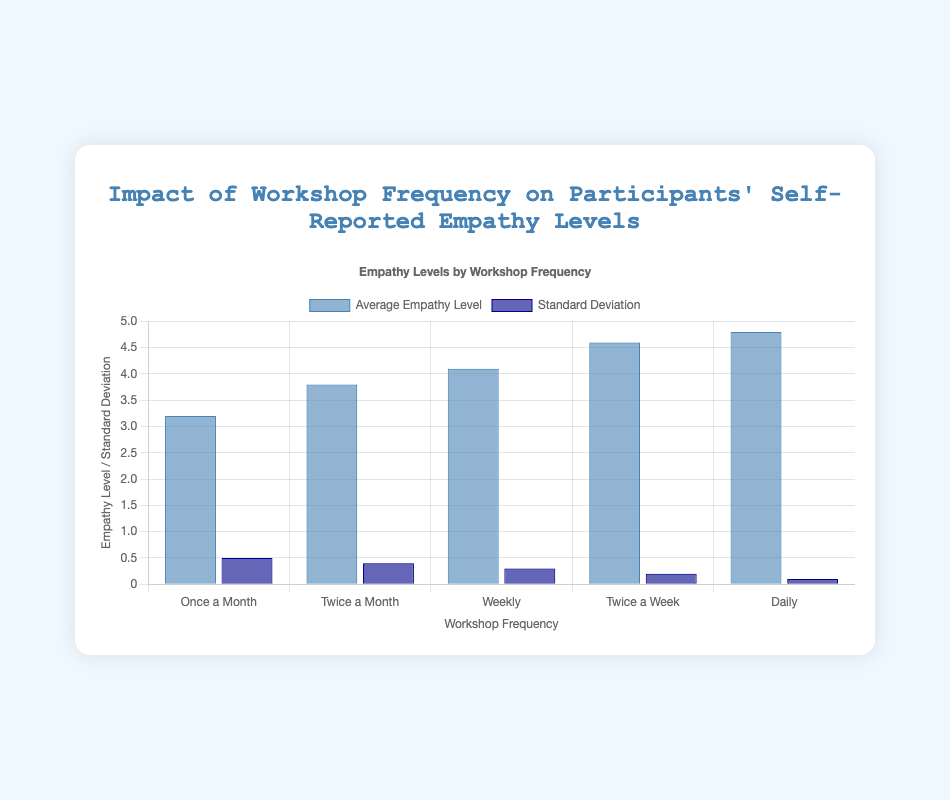Which workshop frequency has the highest average empathy level? By looking at the tallest light blue bar which represents average empathy levels, the "Daily" frequency has the highest value.
Answer: Daily What is the average empathy level for "Twice a Month"? Identify the value of the light blue bar corresponding to "Twice a Month" on the x-axis, which is 3.8.
Answer: 3.8 Compare the standard deviation of empathy levels between "Weekly" and "Twice a Week" workshops. Which one is higher? Look at the dark blue bars for both frequencies. The standard deviation for "Weekly" is 0.3, and for "Twice a Week" it is 0.2. 0.3 is higher than 0.2.
Answer: Weekly How much higher is the average empathy level for "Daily" workshops compared to "Once a Month" workshops? Subtract the "Once a Month" average empathy level (3.2) from the "Daily" average empathy level (4.8). 4.8 - 3.2 = 1.6
Answer: 1.6 What is the difference between the highest and lowest standard deviations? The highest standard deviation is 0.5 for "Once a Month" and the lowest is 0.1 for "Daily". Subtract these values: 0.5 - 0.1 = 0.4
Answer: 0.4 Which workshop frequency has the smallest standard deviation in empathy levels? The shortest dark blue bar represents the smallest standard deviation, which is for "Daily" workshops with a value of 0.1.
Answer: Daily What is the total sum of the average empathy levels for all workshop frequencies combined? Add the average empathy levels for all frequencies: 3.2 + 3.8 + 4.1 + 4.6 + 4.8 = 20.5
Answer: 20.5 Does "Twice a Month" workshop have a higher standard deviation in empathy levels than "Weekly" workshop? Compare dark blue bars for both frequencies. The standard deviation for "Twice a Month" is 0.4 and for "Weekly" it is 0.3. 0.4 > 0.3
Answer: Yes 